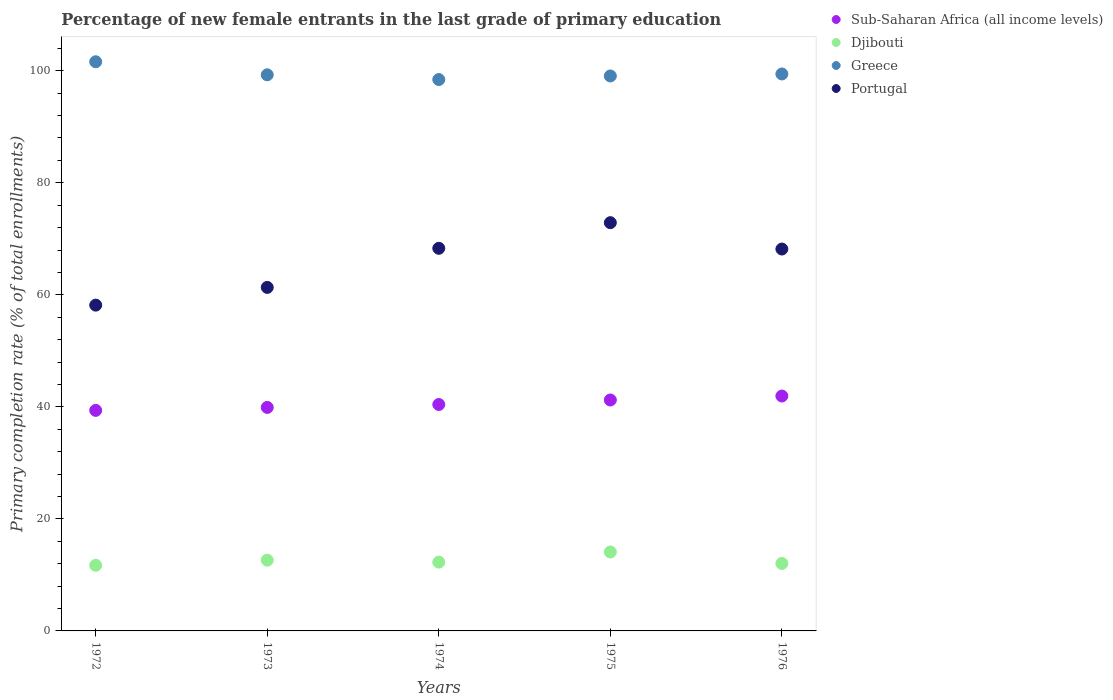How many different coloured dotlines are there?
Offer a very short reply. 4. Is the number of dotlines equal to the number of legend labels?
Provide a succinct answer. Yes. What is the percentage of new female entrants in Portugal in 1973?
Make the answer very short. 61.32. Across all years, what is the maximum percentage of new female entrants in Portugal?
Your response must be concise. 72.88. Across all years, what is the minimum percentage of new female entrants in Portugal?
Provide a succinct answer. 58.16. In which year was the percentage of new female entrants in Djibouti maximum?
Give a very brief answer. 1975. In which year was the percentage of new female entrants in Greece minimum?
Ensure brevity in your answer.  1974. What is the total percentage of new female entrants in Djibouti in the graph?
Your answer should be very brief. 62.76. What is the difference between the percentage of new female entrants in Portugal in 1973 and that in 1976?
Your answer should be compact. -6.85. What is the difference between the percentage of new female entrants in Sub-Saharan Africa (all income levels) in 1973 and the percentage of new female entrants in Greece in 1975?
Your answer should be compact. -59.17. What is the average percentage of new female entrants in Djibouti per year?
Offer a terse response. 12.55. In the year 1974, what is the difference between the percentage of new female entrants in Sub-Saharan Africa (all income levels) and percentage of new female entrants in Portugal?
Your response must be concise. -27.88. In how many years, is the percentage of new female entrants in Greece greater than 48 %?
Keep it short and to the point. 5. What is the ratio of the percentage of new female entrants in Portugal in 1973 to that in 1976?
Offer a very short reply. 0.9. Is the percentage of new female entrants in Sub-Saharan Africa (all income levels) in 1972 less than that in 1976?
Keep it short and to the point. Yes. Is the difference between the percentage of new female entrants in Sub-Saharan Africa (all income levels) in 1972 and 1975 greater than the difference between the percentage of new female entrants in Portugal in 1972 and 1975?
Provide a succinct answer. Yes. What is the difference between the highest and the second highest percentage of new female entrants in Sub-Saharan Africa (all income levels)?
Your response must be concise. 0.71. What is the difference between the highest and the lowest percentage of new female entrants in Sub-Saharan Africa (all income levels)?
Offer a very short reply. 2.56. Is it the case that in every year, the sum of the percentage of new female entrants in Portugal and percentage of new female entrants in Sub-Saharan Africa (all income levels)  is greater than the sum of percentage of new female entrants in Greece and percentage of new female entrants in Djibouti?
Your response must be concise. No. Does the percentage of new female entrants in Portugal monotonically increase over the years?
Make the answer very short. No. What is the difference between two consecutive major ticks on the Y-axis?
Provide a succinct answer. 20. Are the values on the major ticks of Y-axis written in scientific E-notation?
Make the answer very short. No. Does the graph contain grids?
Provide a succinct answer. No. How are the legend labels stacked?
Your answer should be compact. Vertical. What is the title of the graph?
Your answer should be compact. Percentage of new female entrants in the last grade of primary education. What is the label or title of the X-axis?
Provide a short and direct response. Years. What is the label or title of the Y-axis?
Give a very brief answer. Primary completion rate (% of total enrollments). What is the Primary completion rate (% of total enrollments) of Sub-Saharan Africa (all income levels) in 1972?
Your answer should be compact. 39.37. What is the Primary completion rate (% of total enrollments) in Djibouti in 1972?
Offer a very short reply. 11.72. What is the Primary completion rate (% of total enrollments) of Greece in 1972?
Offer a very short reply. 101.61. What is the Primary completion rate (% of total enrollments) in Portugal in 1972?
Your answer should be compact. 58.16. What is the Primary completion rate (% of total enrollments) in Sub-Saharan Africa (all income levels) in 1973?
Offer a terse response. 39.9. What is the Primary completion rate (% of total enrollments) in Djibouti in 1973?
Your answer should be compact. 12.63. What is the Primary completion rate (% of total enrollments) of Greece in 1973?
Offer a terse response. 99.28. What is the Primary completion rate (% of total enrollments) in Portugal in 1973?
Offer a very short reply. 61.32. What is the Primary completion rate (% of total enrollments) in Sub-Saharan Africa (all income levels) in 1974?
Ensure brevity in your answer.  40.42. What is the Primary completion rate (% of total enrollments) in Djibouti in 1974?
Offer a very short reply. 12.28. What is the Primary completion rate (% of total enrollments) of Greece in 1974?
Offer a very short reply. 98.43. What is the Primary completion rate (% of total enrollments) of Portugal in 1974?
Make the answer very short. 68.31. What is the Primary completion rate (% of total enrollments) of Sub-Saharan Africa (all income levels) in 1975?
Your answer should be very brief. 41.23. What is the Primary completion rate (% of total enrollments) of Djibouti in 1975?
Provide a short and direct response. 14.09. What is the Primary completion rate (% of total enrollments) in Greece in 1975?
Provide a succinct answer. 99.07. What is the Primary completion rate (% of total enrollments) of Portugal in 1975?
Keep it short and to the point. 72.88. What is the Primary completion rate (% of total enrollments) of Sub-Saharan Africa (all income levels) in 1976?
Ensure brevity in your answer.  41.93. What is the Primary completion rate (% of total enrollments) in Djibouti in 1976?
Make the answer very short. 12.04. What is the Primary completion rate (% of total enrollments) in Greece in 1976?
Keep it short and to the point. 99.43. What is the Primary completion rate (% of total enrollments) of Portugal in 1976?
Your answer should be compact. 68.18. Across all years, what is the maximum Primary completion rate (% of total enrollments) of Sub-Saharan Africa (all income levels)?
Make the answer very short. 41.93. Across all years, what is the maximum Primary completion rate (% of total enrollments) of Djibouti?
Ensure brevity in your answer.  14.09. Across all years, what is the maximum Primary completion rate (% of total enrollments) of Greece?
Keep it short and to the point. 101.61. Across all years, what is the maximum Primary completion rate (% of total enrollments) of Portugal?
Provide a short and direct response. 72.88. Across all years, what is the minimum Primary completion rate (% of total enrollments) of Sub-Saharan Africa (all income levels)?
Provide a succinct answer. 39.37. Across all years, what is the minimum Primary completion rate (% of total enrollments) in Djibouti?
Your answer should be very brief. 11.72. Across all years, what is the minimum Primary completion rate (% of total enrollments) in Greece?
Keep it short and to the point. 98.43. Across all years, what is the minimum Primary completion rate (% of total enrollments) in Portugal?
Ensure brevity in your answer.  58.16. What is the total Primary completion rate (% of total enrollments) in Sub-Saharan Africa (all income levels) in the graph?
Your answer should be very brief. 202.85. What is the total Primary completion rate (% of total enrollments) in Djibouti in the graph?
Offer a very short reply. 62.76. What is the total Primary completion rate (% of total enrollments) of Greece in the graph?
Give a very brief answer. 497.82. What is the total Primary completion rate (% of total enrollments) in Portugal in the graph?
Give a very brief answer. 328.84. What is the difference between the Primary completion rate (% of total enrollments) in Sub-Saharan Africa (all income levels) in 1972 and that in 1973?
Give a very brief answer. -0.53. What is the difference between the Primary completion rate (% of total enrollments) of Djibouti in 1972 and that in 1973?
Ensure brevity in your answer.  -0.91. What is the difference between the Primary completion rate (% of total enrollments) of Greece in 1972 and that in 1973?
Your response must be concise. 2.33. What is the difference between the Primary completion rate (% of total enrollments) of Portugal in 1972 and that in 1973?
Give a very brief answer. -3.16. What is the difference between the Primary completion rate (% of total enrollments) in Sub-Saharan Africa (all income levels) in 1972 and that in 1974?
Provide a succinct answer. -1.05. What is the difference between the Primary completion rate (% of total enrollments) in Djibouti in 1972 and that in 1974?
Offer a terse response. -0.56. What is the difference between the Primary completion rate (% of total enrollments) of Greece in 1972 and that in 1974?
Keep it short and to the point. 3.18. What is the difference between the Primary completion rate (% of total enrollments) of Portugal in 1972 and that in 1974?
Your response must be concise. -10.15. What is the difference between the Primary completion rate (% of total enrollments) in Sub-Saharan Africa (all income levels) in 1972 and that in 1975?
Give a very brief answer. -1.86. What is the difference between the Primary completion rate (% of total enrollments) in Djibouti in 1972 and that in 1975?
Your answer should be very brief. -2.38. What is the difference between the Primary completion rate (% of total enrollments) in Greece in 1972 and that in 1975?
Provide a short and direct response. 2.54. What is the difference between the Primary completion rate (% of total enrollments) in Portugal in 1972 and that in 1975?
Your answer should be very brief. -14.72. What is the difference between the Primary completion rate (% of total enrollments) of Sub-Saharan Africa (all income levels) in 1972 and that in 1976?
Your answer should be very brief. -2.56. What is the difference between the Primary completion rate (% of total enrollments) in Djibouti in 1972 and that in 1976?
Offer a very short reply. -0.33. What is the difference between the Primary completion rate (% of total enrollments) of Greece in 1972 and that in 1976?
Your answer should be compact. 2.18. What is the difference between the Primary completion rate (% of total enrollments) in Portugal in 1972 and that in 1976?
Provide a succinct answer. -10.02. What is the difference between the Primary completion rate (% of total enrollments) in Sub-Saharan Africa (all income levels) in 1973 and that in 1974?
Ensure brevity in your answer.  -0.52. What is the difference between the Primary completion rate (% of total enrollments) in Djibouti in 1973 and that in 1974?
Provide a succinct answer. 0.35. What is the difference between the Primary completion rate (% of total enrollments) of Greece in 1973 and that in 1974?
Your answer should be very brief. 0.84. What is the difference between the Primary completion rate (% of total enrollments) in Portugal in 1973 and that in 1974?
Provide a succinct answer. -6.98. What is the difference between the Primary completion rate (% of total enrollments) of Sub-Saharan Africa (all income levels) in 1973 and that in 1975?
Make the answer very short. -1.32. What is the difference between the Primary completion rate (% of total enrollments) of Djibouti in 1973 and that in 1975?
Keep it short and to the point. -1.46. What is the difference between the Primary completion rate (% of total enrollments) in Greece in 1973 and that in 1975?
Your answer should be very brief. 0.21. What is the difference between the Primary completion rate (% of total enrollments) of Portugal in 1973 and that in 1975?
Your response must be concise. -11.56. What is the difference between the Primary completion rate (% of total enrollments) of Sub-Saharan Africa (all income levels) in 1973 and that in 1976?
Offer a terse response. -2.03. What is the difference between the Primary completion rate (% of total enrollments) of Djibouti in 1973 and that in 1976?
Provide a short and direct response. 0.59. What is the difference between the Primary completion rate (% of total enrollments) of Greece in 1973 and that in 1976?
Ensure brevity in your answer.  -0.15. What is the difference between the Primary completion rate (% of total enrollments) in Portugal in 1973 and that in 1976?
Provide a succinct answer. -6.85. What is the difference between the Primary completion rate (% of total enrollments) of Sub-Saharan Africa (all income levels) in 1974 and that in 1975?
Make the answer very short. -0.81. What is the difference between the Primary completion rate (% of total enrollments) of Djibouti in 1974 and that in 1975?
Keep it short and to the point. -1.81. What is the difference between the Primary completion rate (% of total enrollments) in Greece in 1974 and that in 1975?
Your response must be concise. -0.64. What is the difference between the Primary completion rate (% of total enrollments) in Portugal in 1974 and that in 1975?
Your response must be concise. -4.58. What is the difference between the Primary completion rate (% of total enrollments) of Sub-Saharan Africa (all income levels) in 1974 and that in 1976?
Keep it short and to the point. -1.51. What is the difference between the Primary completion rate (% of total enrollments) of Djibouti in 1974 and that in 1976?
Provide a succinct answer. 0.24. What is the difference between the Primary completion rate (% of total enrollments) in Greece in 1974 and that in 1976?
Your response must be concise. -0.99. What is the difference between the Primary completion rate (% of total enrollments) of Portugal in 1974 and that in 1976?
Ensure brevity in your answer.  0.13. What is the difference between the Primary completion rate (% of total enrollments) of Sub-Saharan Africa (all income levels) in 1975 and that in 1976?
Offer a very short reply. -0.71. What is the difference between the Primary completion rate (% of total enrollments) in Djibouti in 1975 and that in 1976?
Provide a succinct answer. 2.05. What is the difference between the Primary completion rate (% of total enrollments) of Greece in 1975 and that in 1976?
Give a very brief answer. -0.36. What is the difference between the Primary completion rate (% of total enrollments) in Portugal in 1975 and that in 1976?
Your response must be concise. 4.71. What is the difference between the Primary completion rate (% of total enrollments) in Sub-Saharan Africa (all income levels) in 1972 and the Primary completion rate (% of total enrollments) in Djibouti in 1973?
Give a very brief answer. 26.74. What is the difference between the Primary completion rate (% of total enrollments) of Sub-Saharan Africa (all income levels) in 1972 and the Primary completion rate (% of total enrollments) of Greece in 1973?
Your answer should be very brief. -59.91. What is the difference between the Primary completion rate (% of total enrollments) of Sub-Saharan Africa (all income levels) in 1972 and the Primary completion rate (% of total enrollments) of Portugal in 1973?
Your answer should be compact. -21.95. What is the difference between the Primary completion rate (% of total enrollments) in Djibouti in 1972 and the Primary completion rate (% of total enrollments) in Greece in 1973?
Your answer should be very brief. -87.56. What is the difference between the Primary completion rate (% of total enrollments) of Djibouti in 1972 and the Primary completion rate (% of total enrollments) of Portugal in 1973?
Give a very brief answer. -49.61. What is the difference between the Primary completion rate (% of total enrollments) in Greece in 1972 and the Primary completion rate (% of total enrollments) in Portugal in 1973?
Offer a very short reply. 40.28. What is the difference between the Primary completion rate (% of total enrollments) of Sub-Saharan Africa (all income levels) in 1972 and the Primary completion rate (% of total enrollments) of Djibouti in 1974?
Make the answer very short. 27.09. What is the difference between the Primary completion rate (% of total enrollments) of Sub-Saharan Africa (all income levels) in 1972 and the Primary completion rate (% of total enrollments) of Greece in 1974?
Give a very brief answer. -59.06. What is the difference between the Primary completion rate (% of total enrollments) of Sub-Saharan Africa (all income levels) in 1972 and the Primary completion rate (% of total enrollments) of Portugal in 1974?
Your answer should be compact. -28.93. What is the difference between the Primary completion rate (% of total enrollments) of Djibouti in 1972 and the Primary completion rate (% of total enrollments) of Greece in 1974?
Provide a succinct answer. -86.72. What is the difference between the Primary completion rate (% of total enrollments) in Djibouti in 1972 and the Primary completion rate (% of total enrollments) in Portugal in 1974?
Make the answer very short. -56.59. What is the difference between the Primary completion rate (% of total enrollments) in Greece in 1972 and the Primary completion rate (% of total enrollments) in Portugal in 1974?
Your response must be concise. 33.3. What is the difference between the Primary completion rate (% of total enrollments) of Sub-Saharan Africa (all income levels) in 1972 and the Primary completion rate (% of total enrollments) of Djibouti in 1975?
Provide a short and direct response. 25.28. What is the difference between the Primary completion rate (% of total enrollments) of Sub-Saharan Africa (all income levels) in 1972 and the Primary completion rate (% of total enrollments) of Greece in 1975?
Your answer should be very brief. -59.7. What is the difference between the Primary completion rate (% of total enrollments) in Sub-Saharan Africa (all income levels) in 1972 and the Primary completion rate (% of total enrollments) in Portugal in 1975?
Provide a short and direct response. -33.51. What is the difference between the Primary completion rate (% of total enrollments) in Djibouti in 1972 and the Primary completion rate (% of total enrollments) in Greece in 1975?
Offer a very short reply. -87.35. What is the difference between the Primary completion rate (% of total enrollments) of Djibouti in 1972 and the Primary completion rate (% of total enrollments) of Portugal in 1975?
Offer a terse response. -61.16. What is the difference between the Primary completion rate (% of total enrollments) in Greece in 1972 and the Primary completion rate (% of total enrollments) in Portugal in 1975?
Your response must be concise. 28.73. What is the difference between the Primary completion rate (% of total enrollments) in Sub-Saharan Africa (all income levels) in 1972 and the Primary completion rate (% of total enrollments) in Djibouti in 1976?
Offer a terse response. 27.33. What is the difference between the Primary completion rate (% of total enrollments) in Sub-Saharan Africa (all income levels) in 1972 and the Primary completion rate (% of total enrollments) in Greece in 1976?
Provide a succinct answer. -60.06. What is the difference between the Primary completion rate (% of total enrollments) in Sub-Saharan Africa (all income levels) in 1972 and the Primary completion rate (% of total enrollments) in Portugal in 1976?
Your response must be concise. -28.8. What is the difference between the Primary completion rate (% of total enrollments) of Djibouti in 1972 and the Primary completion rate (% of total enrollments) of Greece in 1976?
Your answer should be very brief. -87.71. What is the difference between the Primary completion rate (% of total enrollments) of Djibouti in 1972 and the Primary completion rate (% of total enrollments) of Portugal in 1976?
Provide a succinct answer. -56.46. What is the difference between the Primary completion rate (% of total enrollments) of Greece in 1972 and the Primary completion rate (% of total enrollments) of Portugal in 1976?
Provide a short and direct response. 33.43. What is the difference between the Primary completion rate (% of total enrollments) in Sub-Saharan Africa (all income levels) in 1973 and the Primary completion rate (% of total enrollments) in Djibouti in 1974?
Provide a succinct answer. 27.62. What is the difference between the Primary completion rate (% of total enrollments) in Sub-Saharan Africa (all income levels) in 1973 and the Primary completion rate (% of total enrollments) in Greece in 1974?
Make the answer very short. -58.53. What is the difference between the Primary completion rate (% of total enrollments) of Sub-Saharan Africa (all income levels) in 1973 and the Primary completion rate (% of total enrollments) of Portugal in 1974?
Provide a short and direct response. -28.4. What is the difference between the Primary completion rate (% of total enrollments) of Djibouti in 1973 and the Primary completion rate (% of total enrollments) of Greece in 1974?
Give a very brief answer. -85.8. What is the difference between the Primary completion rate (% of total enrollments) of Djibouti in 1973 and the Primary completion rate (% of total enrollments) of Portugal in 1974?
Your answer should be very brief. -55.67. What is the difference between the Primary completion rate (% of total enrollments) of Greece in 1973 and the Primary completion rate (% of total enrollments) of Portugal in 1974?
Provide a succinct answer. 30.97. What is the difference between the Primary completion rate (% of total enrollments) of Sub-Saharan Africa (all income levels) in 1973 and the Primary completion rate (% of total enrollments) of Djibouti in 1975?
Provide a short and direct response. 25.81. What is the difference between the Primary completion rate (% of total enrollments) in Sub-Saharan Africa (all income levels) in 1973 and the Primary completion rate (% of total enrollments) in Greece in 1975?
Your answer should be compact. -59.17. What is the difference between the Primary completion rate (% of total enrollments) of Sub-Saharan Africa (all income levels) in 1973 and the Primary completion rate (% of total enrollments) of Portugal in 1975?
Ensure brevity in your answer.  -32.98. What is the difference between the Primary completion rate (% of total enrollments) of Djibouti in 1973 and the Primary completion rate (% of total enrollments) of Greece in 1975?
Your answer should be compact. -86.44. What is the difference between the Primary completion rate (% of total enrollments) in Djibouti in 1973 and the Primary completion rate (% of total enrollments) in Portugal in 1975?
Make the answer very short. -60.25. What is the difference between the Primary completion rate (% of total enrollments) of Greece in 1973 and the Primary completion rate (% of total enrollments) of Portugal in 1975?
Ensure brevity in your answer.  26.4. What is the difference between the Primary completion rate (% of total enrollments) in Sub-Saharan Africa (all income levels) in 1973 and the Primary completion rate (% of total enrollments) in Djibouti in 1976?
Provide a succinct answer. 27.86. What is the difference between the Primary completion rate (% of total enrollments) in Sub-Saharan Africa (all income levels) in 1973 and the Primary completion rate (% of total enrollments) in Greece in 1976?
Your answer should be compact. -59.53. What is the difference between the Primary completion rate (% of total enrollments) of Sub-Saharan Africa (all income levels) in 1973 and the Primary completion rate (% of total enrollments) of Portugal in 1976?
Ensure brevity in your answer.  -28.27. What is the difference between the Primary completion rate (% of total enrollments) of Djibouti in 1973 and the Primary completion rate (% of total enrollments) of Greece in 1976?
Keep it short and to the point. -86.8. What is the difference between the Primary completion rate (% of total enrollments) of Djibouti in 1973 and the Primary completion rate (% of total enrollments) of Portugal in 1976?
Your response must be concise. -55.54. What is the difference between the Primary completion rate (% of total enrollments) in Greece in 1973 and the Primary completion rate (% of total enrollments) in Portugal in 1976?
Keep it short and to the point. 31.1. What is the difference between the Primary completion rate (% of total enrollments) in Sub-Saharan Africa (all income levels) in 1974 and the Primary completion rate (% of total enrollments) in Djibouti in 1975?
Keep it short and to the point. 26.33. What is the difference between the Primary completion rate (% of total enrollments) of Sub-Saharan Africa (all income levels) in 1974 and the Primary completion rate (% of total enrollments) of Greece in 1975?
Give a very brief answer. -58.65. What is the difference between the Primary completion rate (% of total enrollments) of Sub-Saharan Africa (all income levels) in 1974 and the Primary completion rate (% of total enrollments) of Portugal in 1975?
Your response must be concise. -32.46. What is the difference between the Primary completion rate (% of total enrollments) in Djibouti in 1974 and the Primary completion rate (% of total enrollments) in Greece in 1975?
Provide a short and direct response. -86.79. What is the difference between the Primary completion rate (% of total enrollments) of Djibouti in 1974 and the Primary completion rate (% of total enrollments) of Portugal in 1975?
Give a very brief answer. -60.6. What is the difference between the Primary completion rate (% of total enrollments) of Greece in 1974 and the Primary completion rate (% of total enrollments) of Portugal in 1975?
Ensure brevity in your answer.  25.55. What is the difference between the Primary completion rate (% of total enrollments) in Sub-Saharan Africa (all income levels) in 1974 and the Primary completion rate (% of total enrollments) in Djibouti in 1976?
Give a very brief answer. 28.38. What is the difference between the Primary completion rate (% of total enrollments) in Sub-Saharan Africa (all income levels) in 1974 and the Primary completion rate (% of total enrollments) in Greece in 1976?
Your answer should be compact. -59.01. What is the difference between the Primary completion rate (% of total enrollments) of Sub-Saharan Africa (all income levels) in 1974 and the Primary completion rate (% of total enrollments) of Portugal in 1976?
Make the answer very short. -27.75. What is the difference between the Primary completion rate (% of total enrollments) of Djibouti in 1974 and the Primary completion rate (% of total enrollments) of Greece in 1976?
Your response must be concise. -87.15. What is the difference between the Primary completion rate (% of total enrollments) of Djibouti in 1974 and the Primary completion rate (% of total enrollments) of Portugal in 1976?
Your answer should be very brief. -55.9. What is the difference between the Primary completion rate (% of total enrollments) in Greece in 1974 and the Primary completion rate (% of total enrollments) in Portugal in 1976?
Ensure brevity in your answer.  30.26. What is the difference between the Primary completion rate (% of total enrollments) in Sub-Saharan Africa (all income levels) in 1975 and the Primary completion rate (% of total enrollments) in Djibouti in 1976?
Give a very brief answer. 29.18. What is the difference between the Primary completion rate (% of total enrollments) of Sub-Saharan Africa (all income levels) in 1975 and the Primary completion rate (% of total enrollments) of Greece in 1976?
Ensure brevity in your answer.  -58.2. What is the difference between the Primary completion rate (% of total enrollments) in Sub-Saharan Africa (all income levels) in 1975 and the Primary completion rate (% of total enrollments) in Portugal in 1976?
Provide a short and direct response. -26.95. What is the difference between the Primary completion rate (% of total enrollments) in Djibouti in 1975 and the Primary completion rate (% of total enrollments) in Greece in 1976?
Offer a terse response. -85.33. What is the difference between the Primary completion rate (% of total enrollments) in Djibouti in 1975 and the Primary completion rate (% of total enrollments) in Portugal in 1976?
Your response must be concise. -54.08. What is the difference between the Primary completion rate (% of total enrollments) of Greece in 1975 and the Primary completion rate (% of total enrollments) of Portugal in 1976?
Provide a succinct answer. 30.89. What is the average Primary completion rate (% of total enrollments) in Sub-Saharan Africa (all income levels) per year?
Offer a terse response. 40.57. What is the average Primary completion rate (% of total enrollments) of Djibouti per year?
Give a very brief answer. 12.55. What is the average Primary completion rate (% of total enrollments) of Greece per year?
Offer a very short reply. 99.56. What is the average Primary completion rate (% of total enrollments) in Portugal per year?
Provide a short and direct response. 65.77. In the year 1972, what is the difference between the Primary completion rate (% of total enrollments) in Sub-Saharan Africa (all income levels) and Primary completion rate (% of total enrollments) in Djibouti?
Keep it short and to the point. 27.66. In the year 1972, what is the difference between the Primary completion rate (% of total enrollments) of Sub-Saharan Africa (all income levels) and Primary completion rate (% of total enrollments) of Greece?
Offer a very short reply. -62.24. In the year 1972, what is the difference between the Primary completion rate (% of total enrollments) of Sub-Saharan Africa (all income levels) and Primary completion rate (% of total enrollments) of Portugal?
Your response must be concise. -18.79. In the year 1972, what is the difference between the Primary completion rate (% of total enrollments) of Djibouti and Primary completion rate (% of total enrollments) of Greece?
Your answer should be compact. -89.89. In the year 1972, what is the difference between the Primary completion rate (% of total enrollments) of Djibouti and Primary completion rate (% of total enrollments) of Portugal?
Your answer should be compact. -46.44. In the year 1972, what is the difference between the Primary completion rate (% of total enrollments) in Greece and Primary completion rate (% of total enrollments) in Portugal?
Provide a short and direct response. 43.45. In the year 1973, what is the difference between the Primary completion rate (% of total enrollments) in Sub-Saharan Africa (all income levels) and Primary completion rate (% of total enrollments) in Djibouti?
Ensure brevity in your answer.  27.27. In the year 1973, what is the difference between the Primary completion rate (% of total enrollments) in Sub-Saharan Africa (all income levels) and Primary completion rate (% of total enrollments) in Greece?
Keep it short and to the point. -59.37. In the year 1973, what is the difference between the Primary completion rate (% of total enrollments) of Sub-Saharan Africa (all income levels) and Primary completion rate (% of total enrollments) of Portugal?
Make the answer very short. -21.42. In the year 1973, what is the difference between the Primary completion rate (% of total enrollments) of Djibouti and Primary completion rate (% of total enrollments) of Greece?
Provide a short and direct response. -86.65. In the year 1973, what is the difference between the Primary completion rate (% of total enrollments) of Djibouti and Primary completion rate (% of total enrollments) of Portugal?
Your answer should be very brief. -48.69. In the year 1973, what is the difference between the Primary completion rate (% of total enrollments) in Greece and Primary completion rate (% of total enrollments) in Portugal?
Keep it short and to the point. 37.95. In the year 1974, what is the difference between the Primary completion rate (% of total enrollments) in Sub-Saharan Africa (all income levels) and Primary completion rate (% of total enrollments) in Djibouti?
Offer a very short reply. 28.14. In the year 1974, what is the difference between the Primary completion rate (% of total enrollments) of Sub-Saharan Africa (all income levels) and Primary completion rate (% of total enrollments) of Greece?
Your response must be concise. -58.01. In the year 1974, what is the difference between the Primary completion rate (% of total enrollments) of Sub-Saharan Africa (all income levels) and Primary completion rate (% of total enrollments) of Portugal?
Ensure brevity in your answer.  -27.88. In the year 1974, what is the difference between the Primary completion rate (% of total enrollments) of Djibouti and Primary completion rate (% of total enrollments) of Greece?
Provide a succinct answer. -86.15. In the year 1974, what is the difference between the Primary completion rate (% of total enrollments) of Djibouti and Primary completion rate (% of total enrollments) of Portugal?
Your response must be concise. -56.02. In the year 1974, what is the difference between the Primary completion rate (% of total enrollments) of Greece and Primary completion rate (% of total enrollments) of Portugal?
Give a very brief answer. 30.13. In the year 1975, what is the difference between the Primary completion rate (% of total enrollments) of Sub-Saharan Africa (all income levels) and Primary completion rate (% of total enrollments) of Djibouti?
Provide a short and direct response. 27.13. In the year 1975, what is the difference between the Primary completion rate (% of total enrollments) of Sub-Saharan Africa (all income levels) and Primary completion rate (% of total enrollments) of Greece?
Your response must be concise. -57.84. In the year 1975, what is the difference between the Primary completion rate (% of total enrollments) of Sub-Saharan Africa (all income levels) and Primary completion rate (% of total enrollments) of Portugal?
Make the answer very short. -31.65. In the year 1975, what is the difference between the Primary completion rate (% of total enrollments) of Djibouti and Primary completion rate (% of total enrollments) of Greece?
Provide a succinct answer. -84.98. In the year 1975, what is the difference between the Primary completion rate (% of total enrollments) of Djibouti and Primary completion rate (% of total enrollments) of Portugal?
Keep it short and to the point. -58.79. In the year 1975, what is the difference between the Primary completion rate (% of total enrollments) of Greece and Primary completion rate (% of total enrollments) of Portugal?
Offer a very short reply. 26.19. In the year 1976, what is the difference between the Primary completion rate (% of total enrollments) in Sub-Saharan Africa (all income levels) and Primary completion rate (% of total enrollments) in Djibouti?
Keep it short and to the point. 29.89. In the year 1976, what is the difference between the Primary completion rate (% of total enrollments) of Sub-Saharan Africa (all income levels) and Primary completion rate (% of total enrollments) of Greece?
Offer a very short reply. -57.49. In the year 1976, what is the difference between the Primary completion rate (% of total enrollments) in Sub-Saharan Africa (all income levels) and Primary completion rate (% of total enrollments) in Portugal?
Offer a very short reply. -26.24. In the year 1976, what is the difference between the Primary completion rate (% of total enrollments) of Djibouti and Primary completion rate (% of total enrollments) of Greece?
Provide a succinct answer. -87.38. In the year 1976, what is the difference between the Primary completion rate (% of total enrollments) of Djibouti and Primary completion rate (% of total enrollments) of Portugal?
Keep it short and to the point. -56.13. In the year 1976, what is the difference between the Primary completion rate (% of total enrollments) of Greece and Primary completion rate (% of total enrollments) of Portugal?
Offer a very short reply. 31.25. What is the ratio of the Primary completion rate (% of total enrollments) of Sub-Saharan Africa (all income levels) in 1972 to that in 1973?
Ensure brevity in your answer.  0.99. What is the ratio of the Primary completion rate (% of total enrollments) of Djibouti in 1972 to that in 1973?
Your answer should be very brief. 0.93. What is the ratio of the Primary completion rate (% of total enrollments) of Greece in 1972 to that in 1973?
Make the answer very short. 1.02. What is the ratio of the Primary completion rate (% of total enrollments) of Portugal in 1972 to that in 1973?
Provide a succinct answer. 0.95. What is the ratio of the Primary completion rate (% of total enrollments) in Sub-Saharan Africa (all income levels) in 1972 to that in 1974?
Ensure brevity in your answer.  0.97. What is the ratio of the Primary completion rate (% of total enrollments) in Djibouti in 1972 to that in 1974?
Provide a succinct answer. 0.95. What is the ratio of the Primary completion rate (% of total enrollments) of Greece in 1972 to that in 1974?
Your answer should be very brief. 1.03. What is the ratio of the Primary completion rate (% of total enrollments) in Portugal in 1972 to that in 1974?
Offer a terse response. 0.85. What is the ratio of the Primary completion rate (% of total enrollments) of Sub-Saharan Africa (all income levels) in 1972 to that in 1975?
Your response must be concise. 0.95. What is the ratio of the Primary completion rate (% of total enrollments) in Djibouti in 1972 to that in 1975?
Your answer should be very brief. 0.83. What is the ratio of the Primary completion rate (% of total enrollments) of Greece in 1972 to that in 1975?
Provide a succinct answer. 1.03. What is the ratio of the Primary completion rate (% of total enrollments) of Portugal in 1972 to that in 1975?
Provide a succinct answer. 0.8. What is the ratio of the Primary completion rate (% of total enrollments) in Sub-Saharan Africa (all income levels) in 1972 to that in 1976?
Ensure brevity in your answer.  0.94. What is the ratio of the Primary completion rate (% of total enrollments) in Djibouti in 1972 to that in 1976?
Keep it short and to the point. 0.97. What is the ratio of the Primary completion rate (% of total enrollments) in Greece in 1972 to that in 1976?
Give a very brief answer. 1.02. What is the ratio of the Primary completion rate (% of total enrollments) in Portugal in 1972 to that in 1976?
Offer a terse response. 0.85. What is the ratio of the Primary completion rate (% of total enrollments) in Sub-Saharan Africa (all income levels) in 1973 to that in 1974?
Offer a very short reply. 0.99. What is the ratio of the Primary completion rate (% of total enrollments) of Djibouti in 1973 to that in 1974?
Your answer should be very brief. 1.03. What is the ratio of the Primary completion rate (% of total enrollments) in Greece in 1973 to that in 1974?
Make the answer very short. 1.01. What is the ratio of the Primary completion rate (% of total enrollments) of Portugal in 1973 to that in 1974?
Keep it short and to the point. 0.9. What is the ratio of the Primary completion rate (% of total enrollments) in Sub-Saharan Africa (all income levels) in 1973 to that in 1975?
Your answer should be very brief. 0.97. What is the ratio of the Primary completion rate (% of total enrollments) in Djibouti in 1973 to that in 1975?
Ensure brevity in your answer.  0.9. What is the ratio of the Primary completion rate (% of total enrollments) in Greece in 1973 to that in 1975?
Your answer should be compact. 1. What is the ratio of the Primary completion rate (% of total enrollments) in Portugal in 1973 to that in 1975?
Your answer should be compact. 0.84. What is the ratio of the Primary completion rate (% of total enrollments) in Sub-Saharan Africa (all income levels) in 1973 to that in 1976?
Offer a terse response. 0.95. What is the ratio of the Primary completion rate (% of total enrollments) in Djibouti in 1973 to that in 1976?
Make the answer very short. 1.05. What is the ratio of the Primary completion rate (% of total enrollments) of Portugal in 1973 to that in 1976?
Make the answer very short. 0.9. What is the ratio of the Primary completion rate (% of total enrollments) in Sub-Saharan Africa (all income levels) in 1974 to that in 1975?
Ensure brevity in your answer.  0.98. What is the ratio of the Primary completion rate (% of total enrollments) in Djibouti in 1974 to that in 1975?
Your response must be concise. 0.87. What is the ratio of the Primary completion rate (% of total enrollments) in Greece in 1974 to that in 1975?
Keep it short and to the point. 0.99. What is the ratio of the Primary completion rate (% of total enrollments) of Portugal in 1974 to that in 1975?
Provide a short and direct response. 0.94. What is the ratio of the Primary completion rate (% of total enrollments) in Sub-Saharan Africa (all income levels) in 1974 to that in 1976?
Your answer should be very brief. 0.96. What is the ratio of the Primary completion rate (% of total enrollments) in Djibouti in 1974 to that in 1976?
Your answer should be compact. 1.02. What is the ratio of the Primary completion rate (% of total enrollments) in Greece in 1974 to that in 1976?
Your answer should be compact. 0.99. What is the ratio of the Primary completion rate (% of total enrollments) in Portugal in 1974 to that in 1976?
Provide a short and direct response. 1. What is the ratio of the Primary completion rate (% of total enrollments) of Sub-Saharan Africa (all income levels) in 1975 to that in 1976?
Ensure brevity in your answer.  0.98. What is the ratio of the Primary completion rate (% of total enrollments) in Djibouti in 1975 to that in 1976?
Offer a terse response. 1.17. What is the ratio of the Primary completion rate (% of total enrollments) in Greece in 1975 to that in 1976?
Offer a very short reply. 1. What is the ratio of the Primary completion rate (% of total enrollments) in Portugal in 1975 to that in 1976?
Provide a short and direct response. 1.07. What is the difference between the highest and the second highest Primary completion rate (% of total enrollments) in Sub-Saharan Africa (all income levels)?
Ensure brevity in your answer.  0.71. What is the difference between the highest and the second highest Primary completion rate (% of total enrollments) in Djibouti?
Your response must be concise. 1.46. What is the difference between the highest and the second highest Primary completion rate (% of total enrollments) of Greece?
Keep it short and to the point. 2.18. What is the difference between the highest and the second highest Primary completion rate (% of total enrollments) of Portugal?
Provide a short and direct response. 4.58. What is the difference between the highest and the lowest Primary completion rate (% of total enrollments) in Sub-Saharan Africa (all income levels)?
Ensure brevity in your answer.  2.56. What is the difference between the highest and the lowest Primary completion rate (% of total enrollments) in Djibouti?
Your response must be concise. 2.38. What is the difference between the highest and the lowest Primary completion rate (% of total enrollments) of Greece?
Your answer should be compact. 3.18. What is the difference between the highest and the lowest Primary completion rate (% of total enrollments) in Portugal?
Offer a terse response. 14.72. 